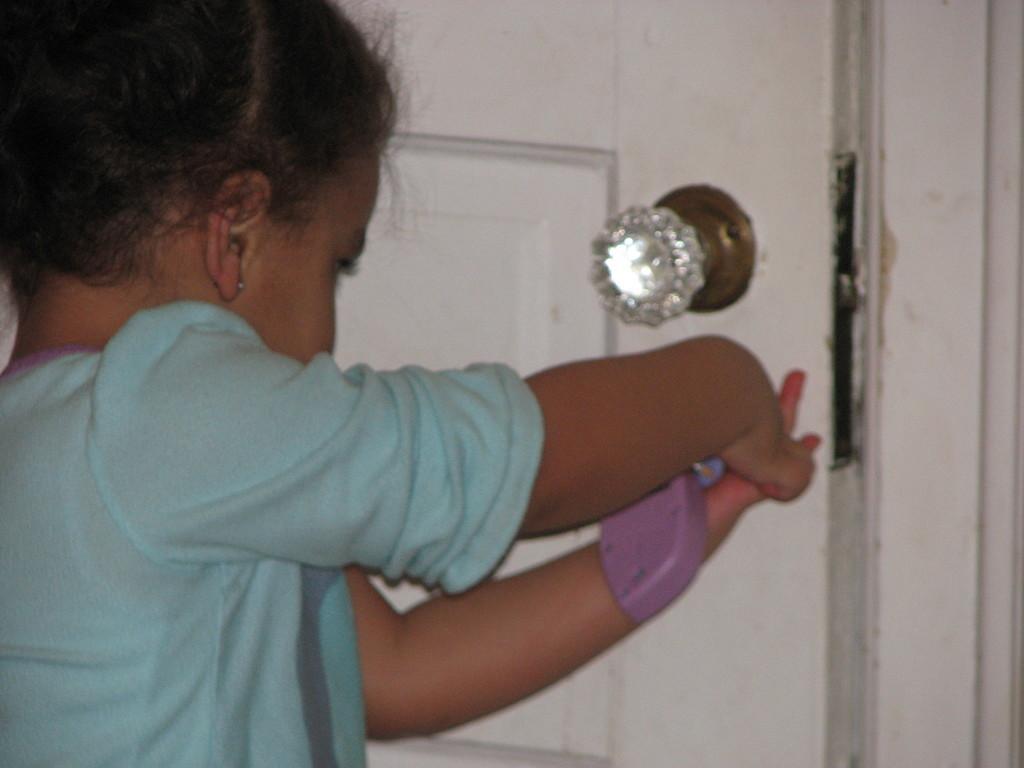Can you describe this image briefly? There is a small girl wearing t shirt and holding some thing in her hand trying to open the door. There is a handle attached to the door. 